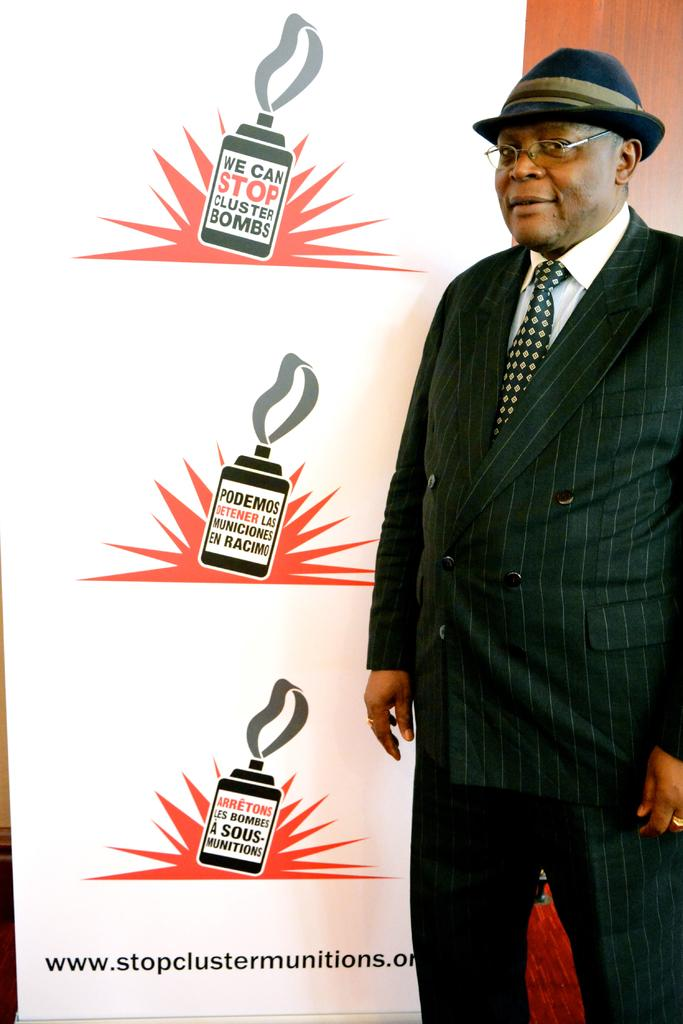Who is present in the image? There is a person in the image. What is the person wearing? The person is wearing a black and white dress, glasses (specs), and a hat. What else can be seen in the image? There is a banner visible in the image. What type of disease is the person suffering from in the image? There is no indication of any disease in the image; the person is simply wearing a black and white dress, glasses, and a hat. 